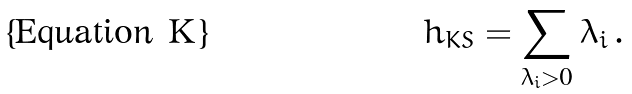Convert formula to latex. <formula><loc_0><loc_0><loc_500><loc_500>h _ { K S } = \sum _ { \lambda _ { i } > 0 } \lambda _ { i } \, .</formula> 